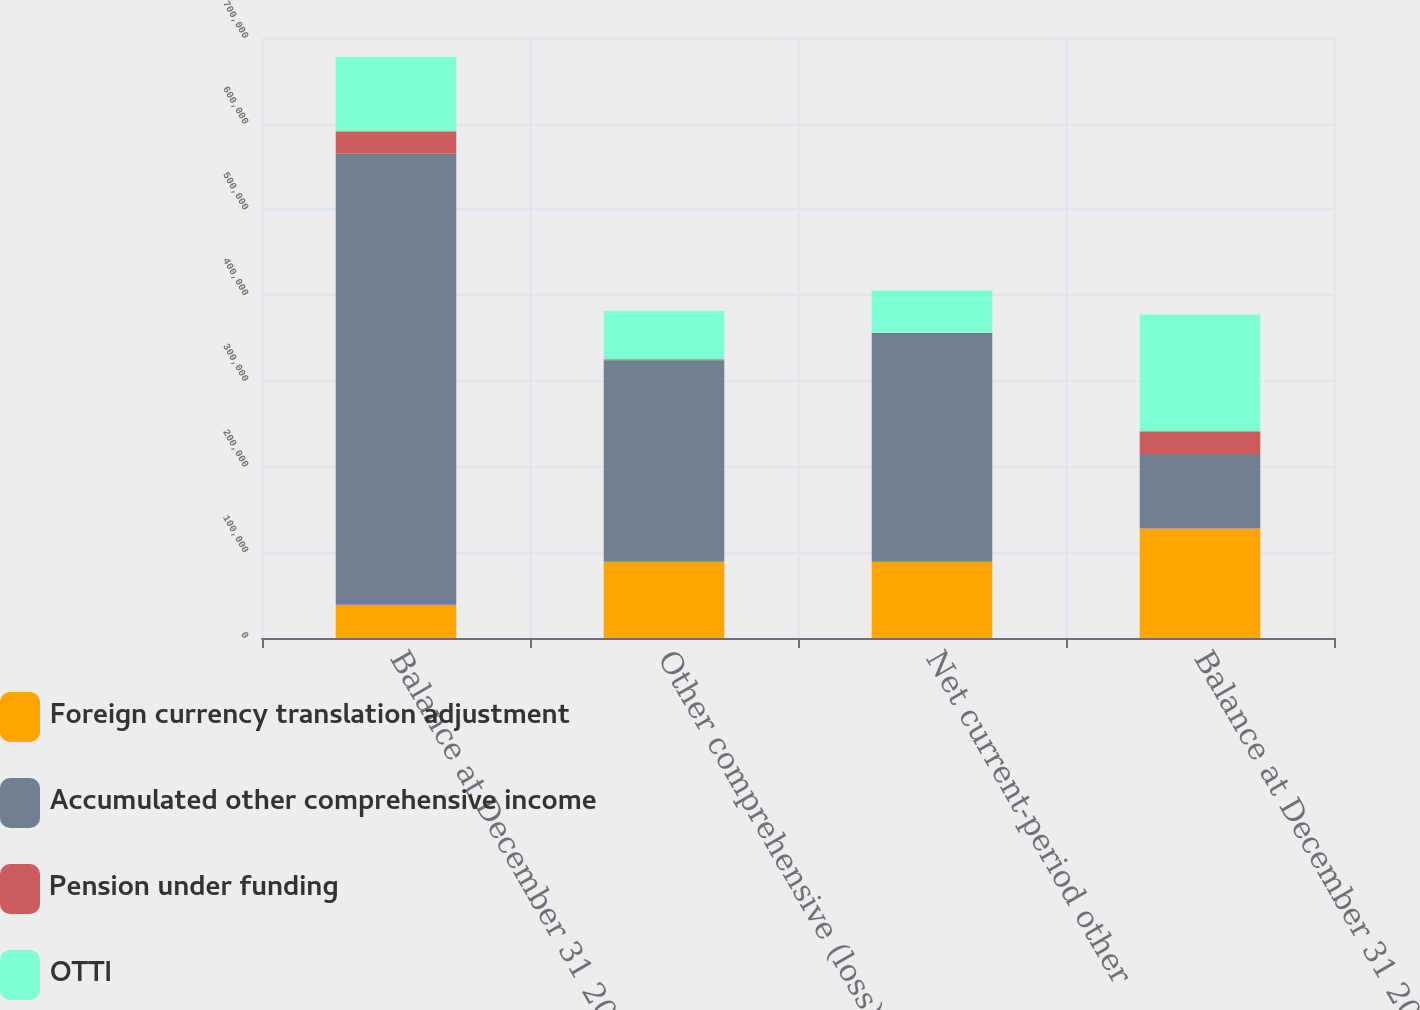Convert chart to OTSL. <chart><loc_0><loc_0><loc_500><loc_500><stacked_bar_chart><ecel><fcel>Balance at December 31 2013<fcel>Other comprehensive (loss)<fcel>Net current-period other<fcel>Balance at December 31 2014<nl><fcel>Foreign currency translation adjustment<fcel>38767<fcel>88944<fcel>88944<fcel>127711<nl><fcel>Accumulated other comprehensive income<fcel>526071<fcel>235000<fcel>267011<fcel>86901<nl><fcel>Pension under funding<fcel>26427<fcel>1321<fcel>167<fcel>26594<nl><fcel>OTTI<fcel>86901<fcel>56647<fcel>49297<fcel>136198<nl></chart> 